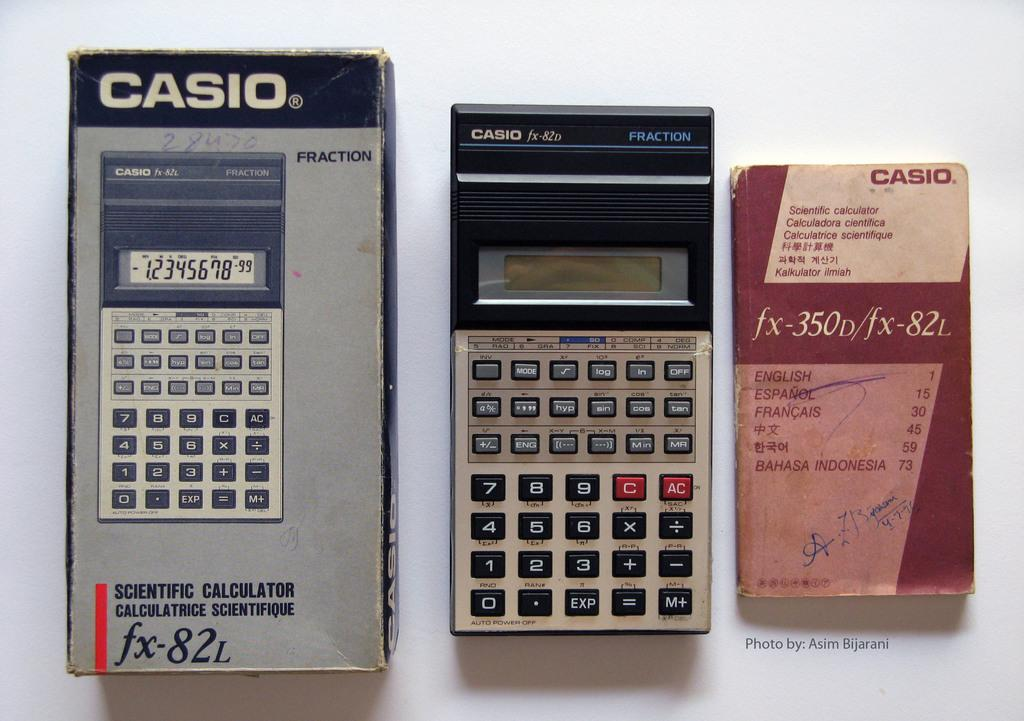<image>
Write a terse but informative summary of the picture. A Casio calculator and it's box are near a Casio pamphlet. 